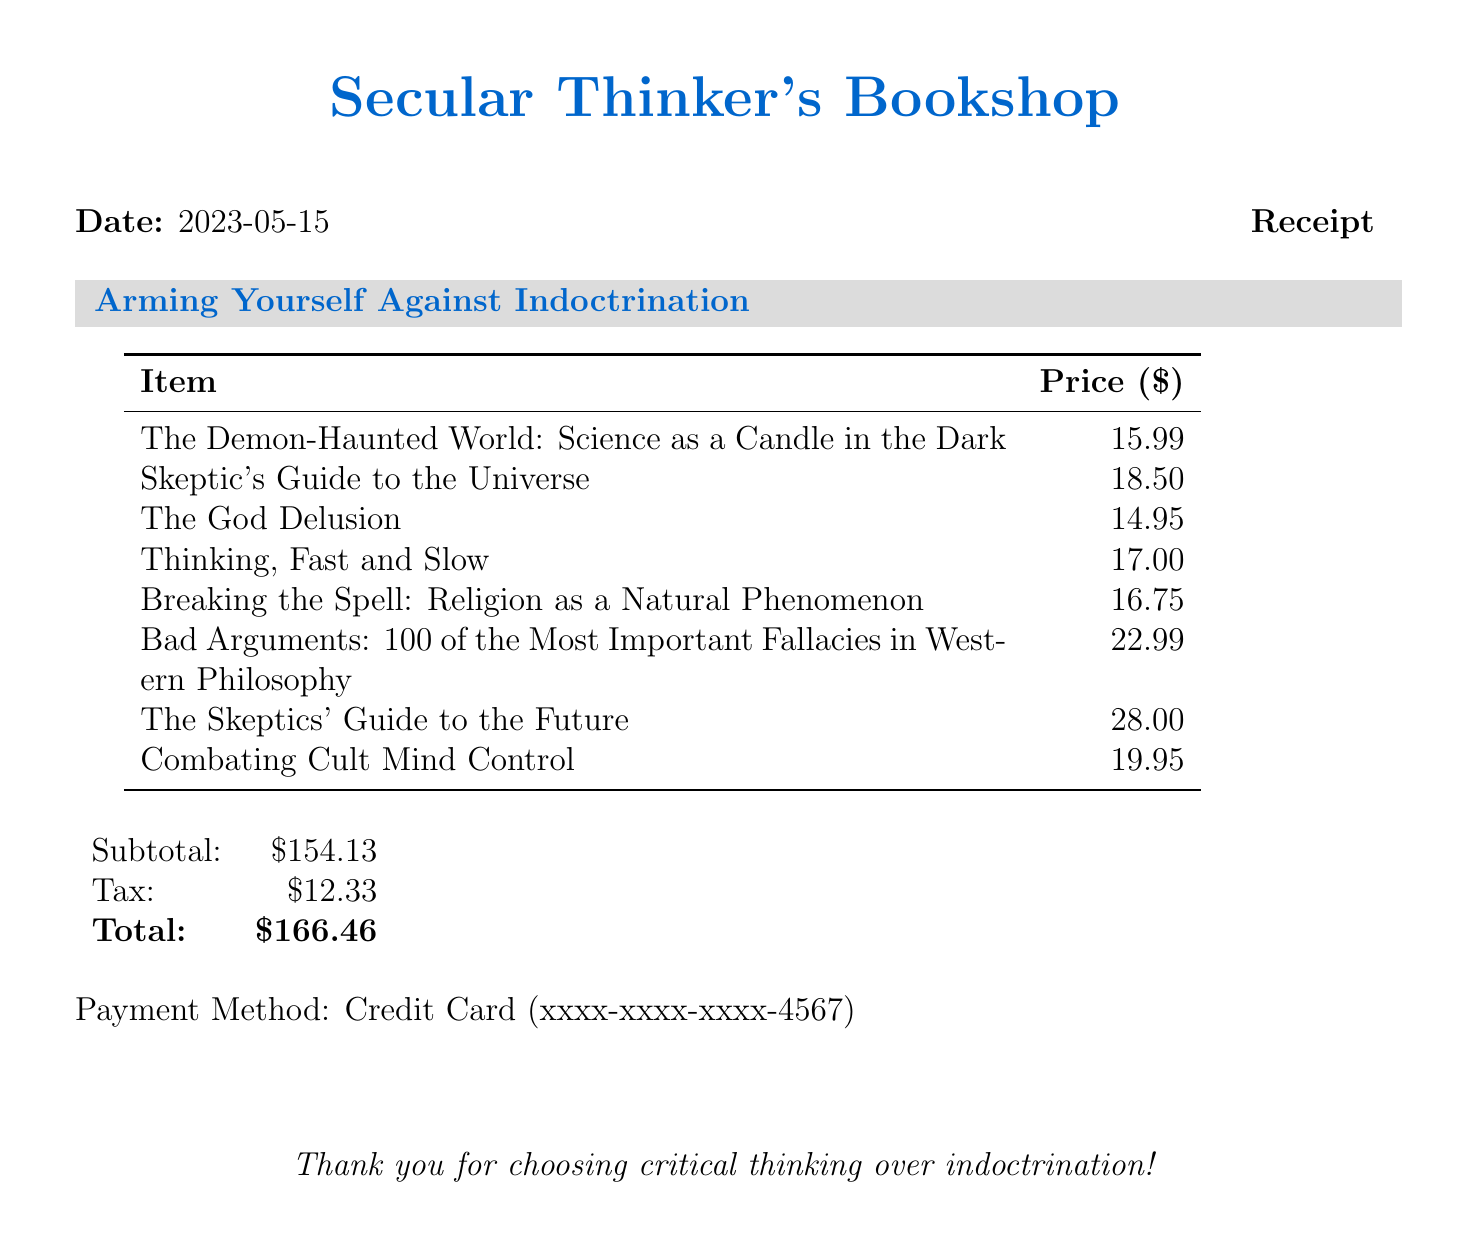What is the name of the bookstore? The name of the bookstore is listed at the top of the document.
Answer: Secular Thinker's Bookshop What is the date of the purchase? The date appears near the top of the receipt.
Answer: 2023-05-15 Who is the author of "The God Delusion"? The author is specified next to the title in the list of items.
Answer: Richard Dawkins What is the price of "Thinking, Fast and Slow"? The price is listed next to the corresponding title in the receipt.
Answer: 17.00 What is the subtotal of the purchase? The subtotal is detailed in a specific section near the end of the document.
Answer: 154.13 What was the total amount paid? The total is emphasized at the bottom of the receipt as the final payment.
Answer: 166.46 Which payment method was used? The payment method is mentioned at the bottom of the receipt.
Answer: Credit Card How many items were purchased? By counting the list of items in the document, we find the total.
Answer: 8 